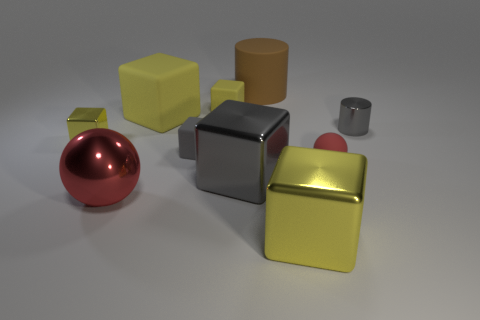There is a big ball that is the same material as the gray cylinder; what is its color?
Offer a terse response. Red. Is the big sphere made of the same material as the large cylinder?
Keep it short and to the point. No. The yellow object in front of the yellow metal thing that is behind the rubber sphere is made of what material?
Ensure brevity in your answer.  Metal. Are there more brown objects behind the brown matte cylinder than tiny purple rubber cylinders?
Provide a short and direct response. No. How many other objects are there of the same size as the matte cylinder?
Your response must be concise. 4. Is the shiny sphere the same color as the small shiny block?
Your response must be concise. No. There is a cylinder that is on the right side of the tiny red sphere that is behind the yellow thing in front of the big red thing; what is its color?
Offer a terse response. Gray. What number of big rubber cylinders are on the left side of the tiny matte block that is in front of the gray object that is on the right side of the brown matte thing?
Your answer should be very brief. 0. Is there anything else of the same color as the big matte cylinder?
Provide a succinct answer. No. There is a cylinder that is to the right of the brown rubber cylinder; is its size the same as the tiny gray cube?
Provide a succinct answer. Yes. 